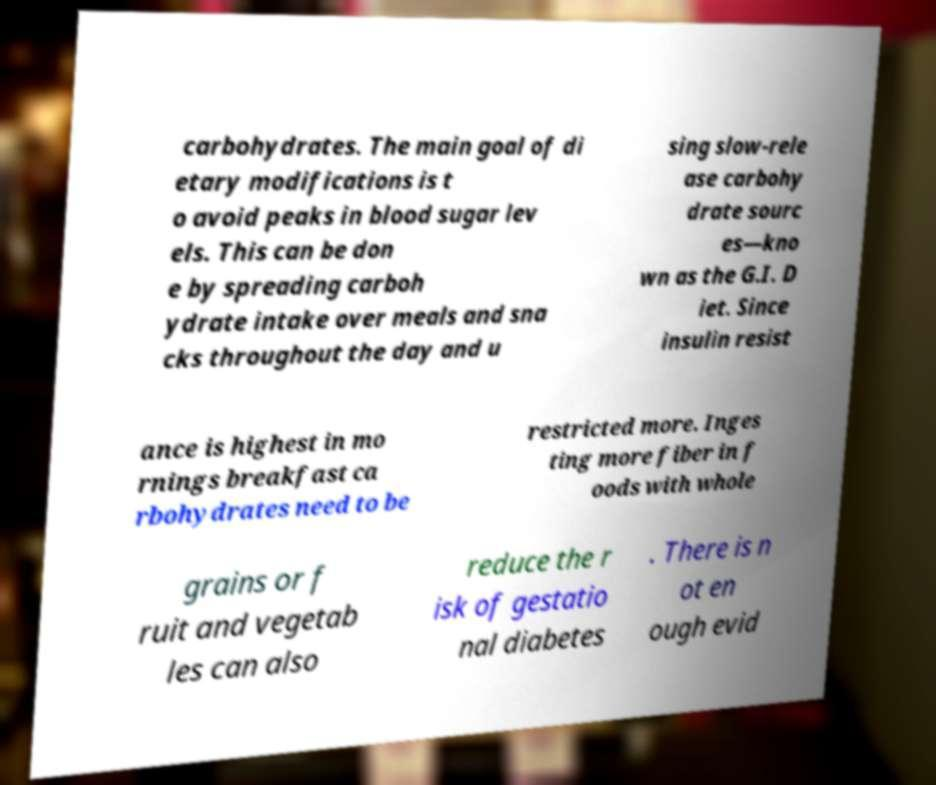Please read and relay the text visible in this image. What does it say? carbohydrates. The main goal of di etary modifications is t o avoid peaks in blood sugar lev els. This can be don e by spreading carboh ydrate intake over meals and sna cks throughout the day and u sing slow-rele ase carbohy drate sourc es—kno wn as the G.I. D iet. Since insulin resist ance is highest in mo rnings breakfast ca rbohydrates need to be restricted more. Inges ting more fiber in f oods with whole grains or f ruit and vegetab les can also reduce the r isk of gestatio nal diabetes . There is n ot en ough evid 